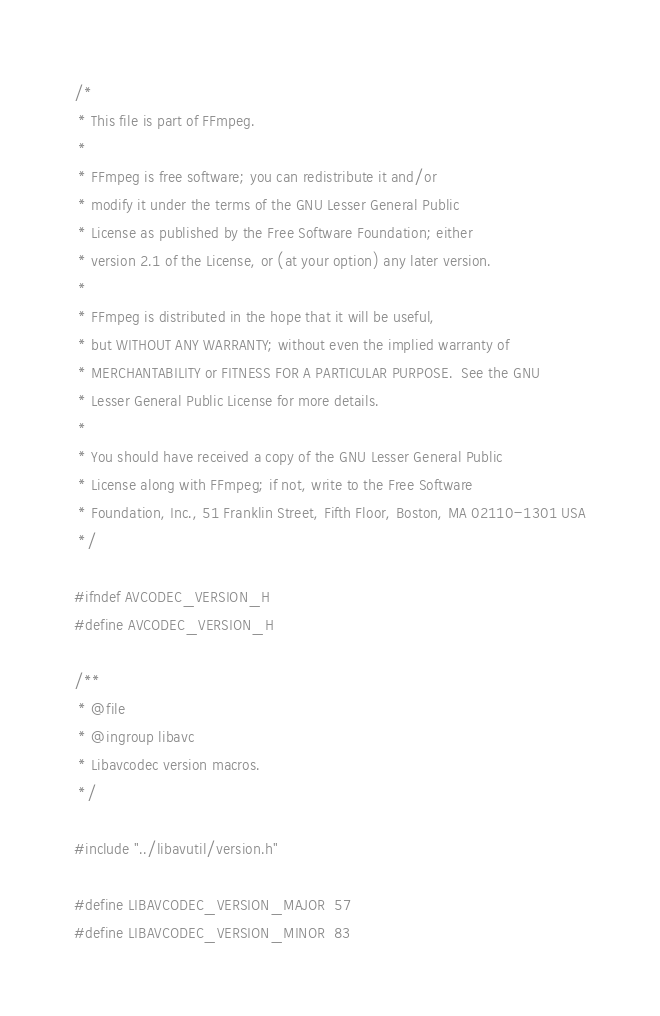Convert code to text. <code><loc_0><loc_0><loc_500><loc_500><_C_>/*
 * This file is part of FFmpeg.
 *
 * FFmpeg is free software; you can redistribute it and/or
 * modify it under the terms of the GNU Lesser General Public
 * License as published by the Free Software Foundation; either
 * version 2.1 of the License, or (at your option) any later version.
 *
 * FFmpeg is distributed in the hope that it will be useful,
 * but WITHOUT ANY WARRANTY; without even the implied warranty of
 * MERCHANTABILITY or FITNESS FOR A PARTICULAR PURPOSE.  See the GNU
 * Lesser General Public License for more details.
 *
 * You should have received a copy of the GNU Lesser General Public
 * License along with FFmpeg; if not, write to the Free Software
 * Foundation, Inc., 51 Franklin Street, Fifth Floor, Boston, MA 02110-1301 USA
 */

#ifndef AVCODEC_VERSION_H
#define AVCODEC_VERSION_H

/**
 * @file
 * @ingroup libavc
 * Libavcodec version macros.
 */

#include "../libavutil/version.h"

#define LIBAVCODEC_VERSION_MAJOR  57
#define LIBAVCODEC_VERSION_MINOR  83</code> 